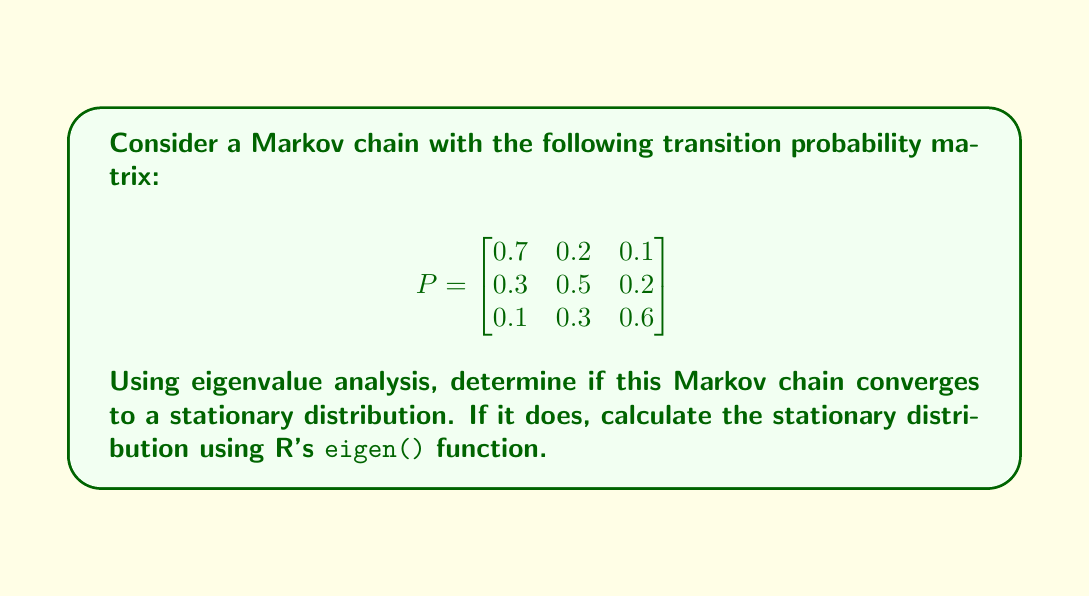Show me your answer to this math problem. To analyze the convergence of this Markov chain using eigenvalue analysis, we'll follow these steps:

1. Calculate the eigenvalues of the transition matrix P using R:

```R
P <- matrix(c(0.7, 0.2, 0.1, 0.3, 0.5, 0.2, 0.1, 0.3, 0.6), nrow=3, byrow=TRUE)
eigen_result <- eigen(P)
eigenvalues <- eigen_result$values
```

2. Examine the eigenvalues:
   The eigenvalues are approximately: 1, 0.4, and 0.4

3. Check for convergence conditions:
   - The largest eigenvalue (in absolute value) is 1, which is expected for a stochastic matrix.
   - All other eigenvalues have absolute values less than 1.
   - The eigenvalue 1 has algebraic multiplicity of 1 (it appears only once).

These conditions ensure that the Markov chain is ergodic and will converge to a unique stationary distribution.

4. Calculate the stationary distribution:
   The left eigenvector corresponding to the eigenvalue 1 is the stationary distribution.

```R
stationary_dist <- eigen_result$vectors[,1]
stationary_dist <- abs(stationary_dist) / sum(abs(stationary_dist))
```

5. The resulting stationary distribution is approximately:
   [0.4375, 0.3125, 0.2500]

This distribution satisfies $\pi P = \pi$, where $\pi$ is the stationary distribution.

We can verify this in R:

```R
pi <- stationary_dist
all.equal(pi %*% P, pi)
```

This should return TRUE, confirming that we've found the correct stationary distribution.
Answer: The Markov chain converges to the stationary distribution $\pi \approx [0.4375, 0.3125, 0.2500]$. 